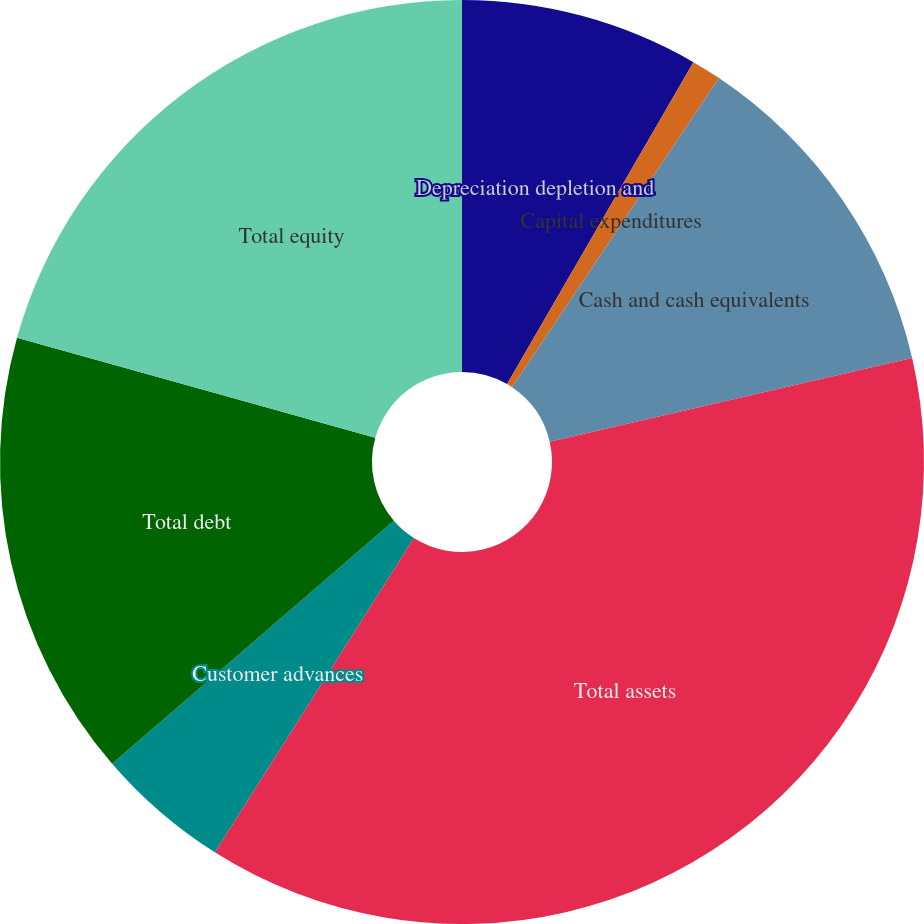Convert chart to OTSL. <chart><loc_0><loc_0><loc_500><loc_500><pie_chart><fcel>Depreciation depletion and<fcel>Capital expenditures<fcel>Cash and cash equivalents<fcel>Total assets<fcel>Customer advances<fcel>Total debt<fcel>Total equity<nl><fcel>8.35%<fcel>1.04%<fcel>12.0%<fcel>37.6%<fcel>4.69%<fcel>15.66%<fcel>20.67%<nl></chart> 